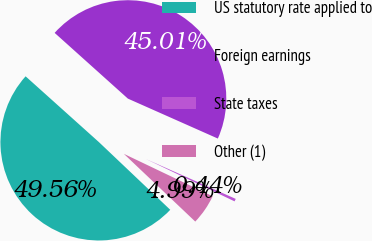Convert chart to OTSL. <chart><loc_0><loc_0><loc_500><loc_500><pie_chart><fcel>US statutory rate applied to<fcel>Foreign earnings<fcel>State taxes<fcel>Other (1)<nl><fcel>49.56%<fcel>45.01%<fcel>0.44%<fcel>4.99%<nl></chart> 